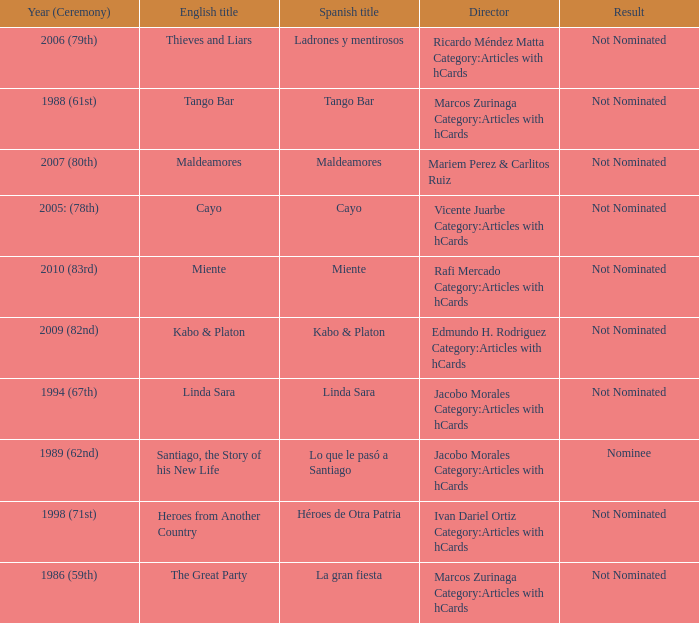What was the English title fo the film that was a nominee? Santiago, the Story of his New Life. 